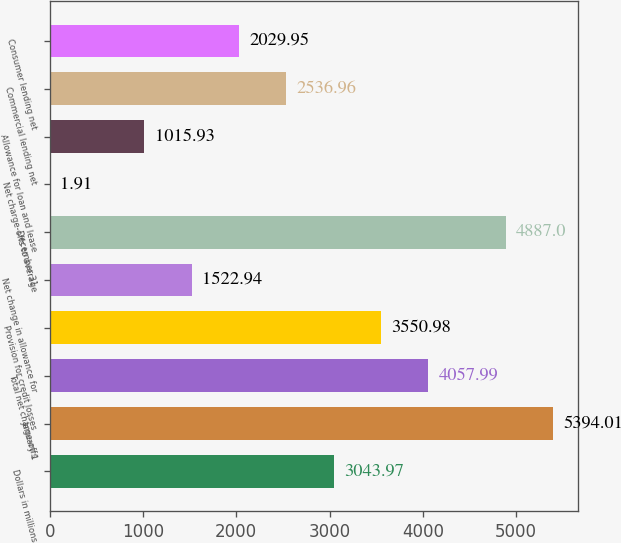<chart> <loc_0><loc_0><loc_500><loc_500><bar_chart><fcel>Dollars in millions<fcel>January 1<fcel>Total net charge-offs<fcel>Provision for credit losses<fcel>Net change in allowance for<fcel>December 31<fcel>Net charge-offs to average<fcel>Allowance for loan and lease<fcel>Commercial lending net<fcel>Consumer lending net<nl><fcel>3043.97<fcel>5394.01<fcel>4057.99<fcel>3550.98<fcel>1522.94<fcel>4887<fcel>1.91<fcel>1015.93<fcel>2536.96<fcel>2029.95<nl></chart> 